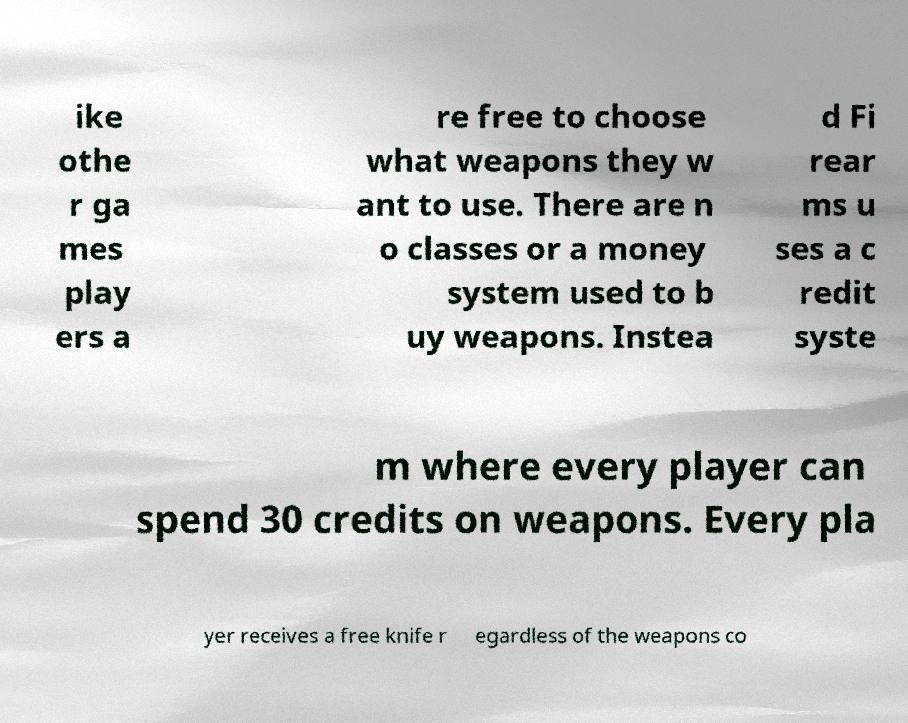Could you assist in decoding the text presented in this image and type it out clearly? ike othe r ga mes play ers a re free to choose what weapons they w ant to use. There are n o classes or a money system used to b uy weapons. Instea d Fi rear ms u ses a c redit syste m where every player can spend 30 credits on weapons. Every pla yer receives a free knife r egardless of the weapons co 